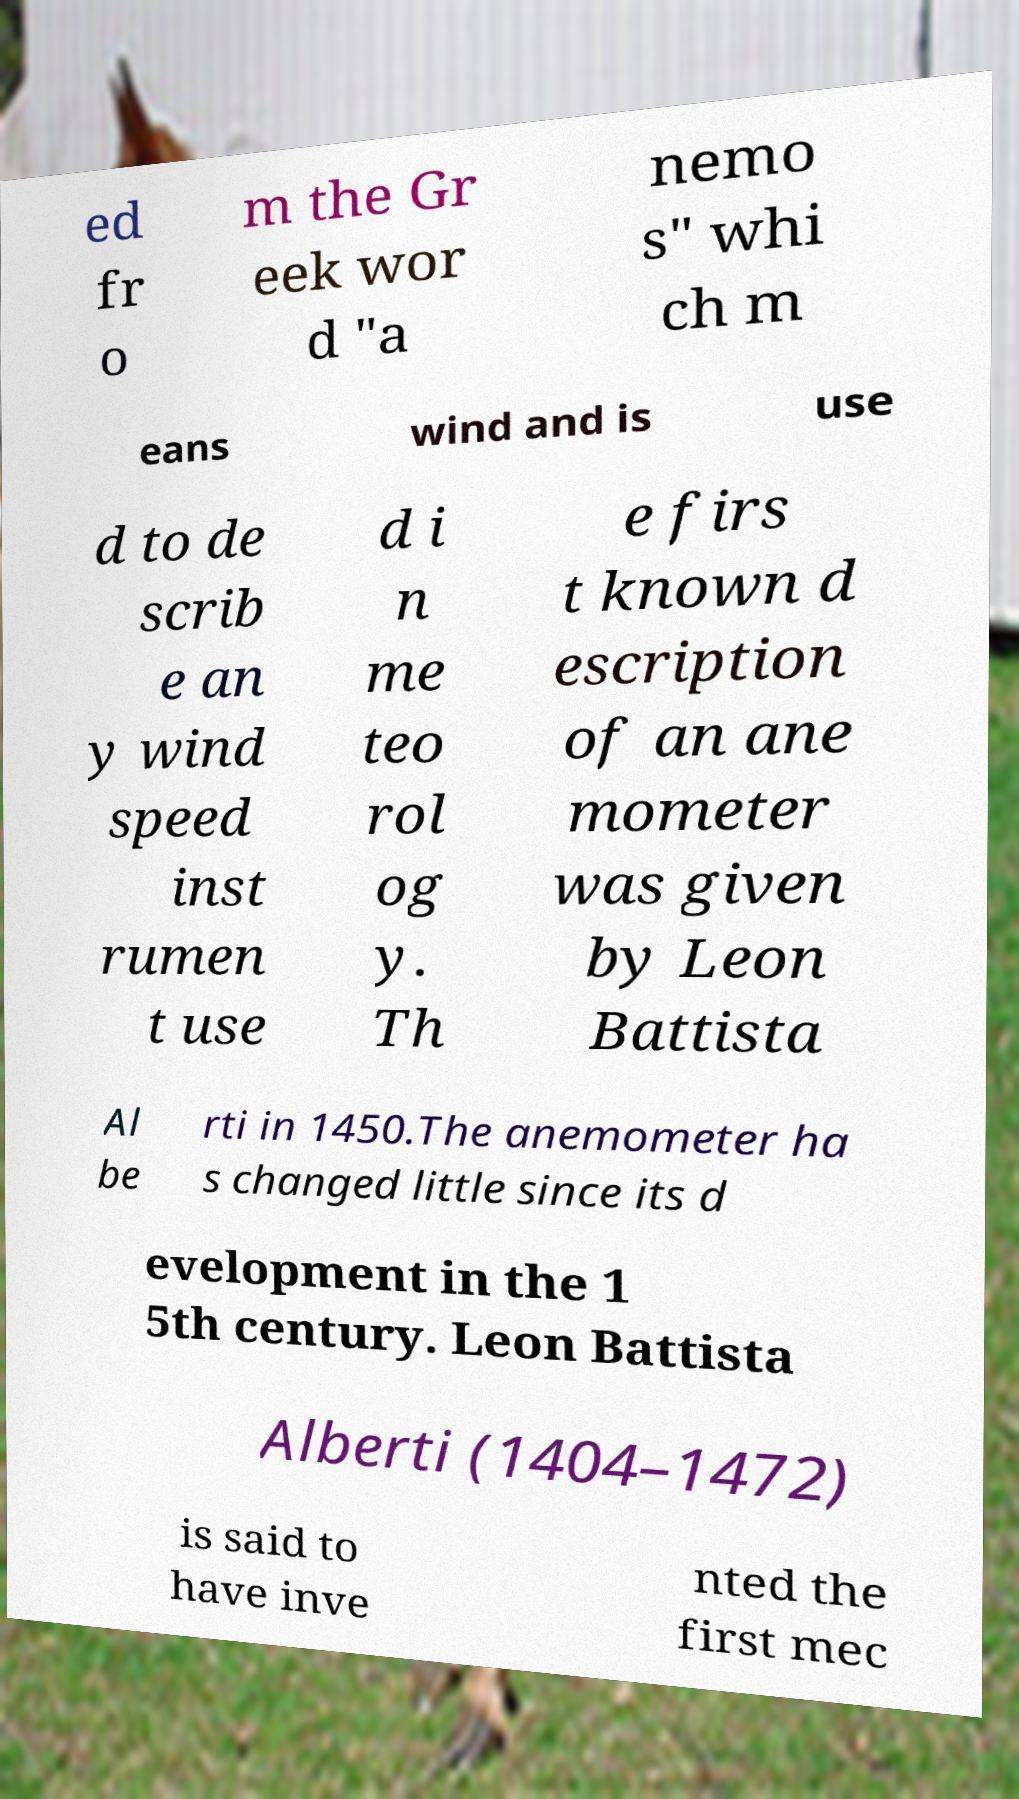Can you read and provide the text displayed in the image?This photo seems to have some interesting text. Can you extract and type it out for me? ed fr o m the Gr eek wor d "a nemo s" whi ch m eans wind and is use d to de scrib e an y wind speed inst rumen t use d i n me teo rol og y. Th e firs t known d escription of an ane mometer was given by Leon Battista Al be rti in 1450.The anemometer ha s changed little since its d evelopment in the 1 5th century. Leon Battista Alberti (1404–1472) is said to have inve nted the first mec 